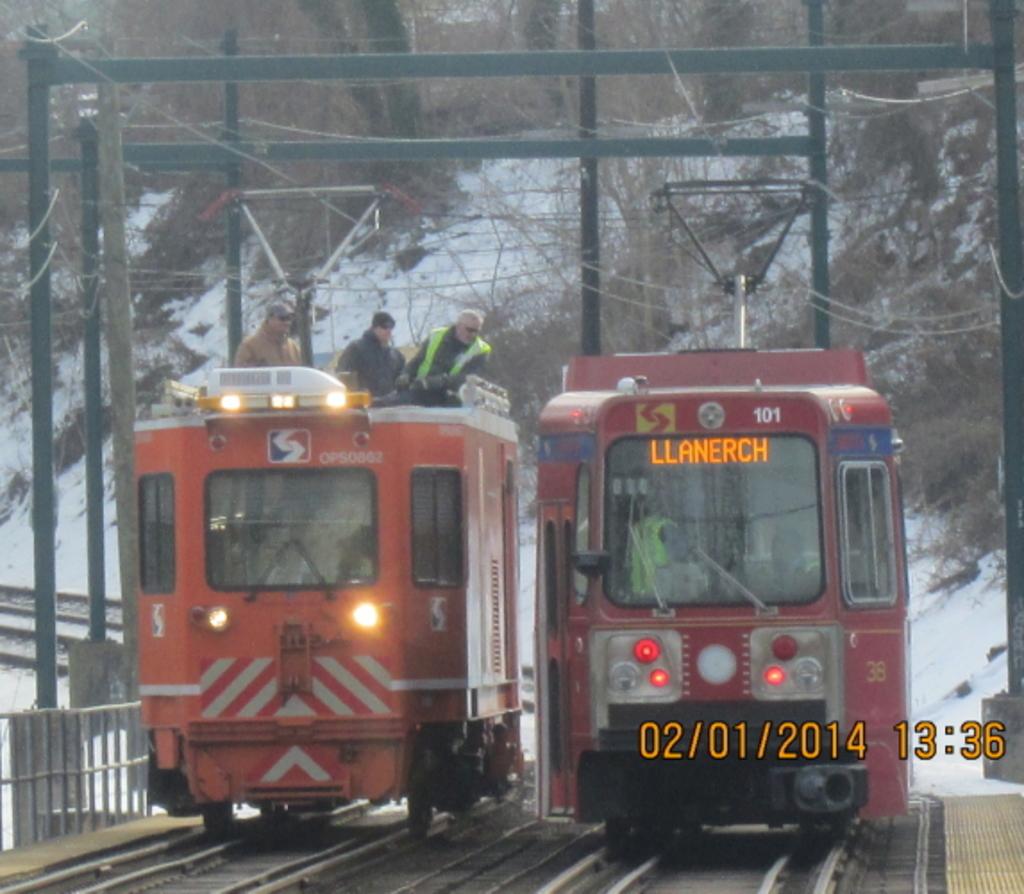What is the number on the top of the bus on the right?
Ensure brevity in your answer.  101. What time was this picture taken?
Provide a succinct answer. 13:36. 